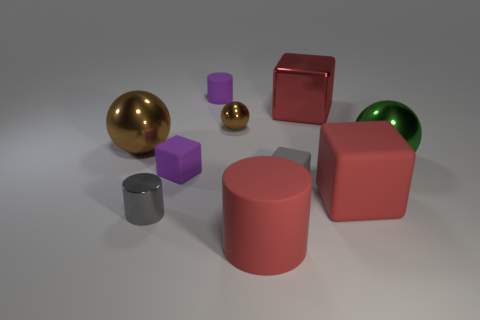Subtract all big brown metal balls. How many balls are left? 2 Subtract 1 balls. How many balls are left? 2 Subtract all red cylinders. How many cylinders are left? 2 Subtract all cylinders. How many objects are left? 7 Subtract all brown cylinders. Subtract all brown cubes. How many cylinders are left? 3 Subtract all cyan cylinders. How many gray cubes are left? 1 Subtract all gray metallic things. Subtract all large metallic balls. How many objects are left? 7 Add 1 red cylinders. How many red cylinders are left? 2 Add 9 big brown metallic spheres. How many big brown metallic spheres exist? 10 Subtract 1 green balls. How many objects are left? 9 